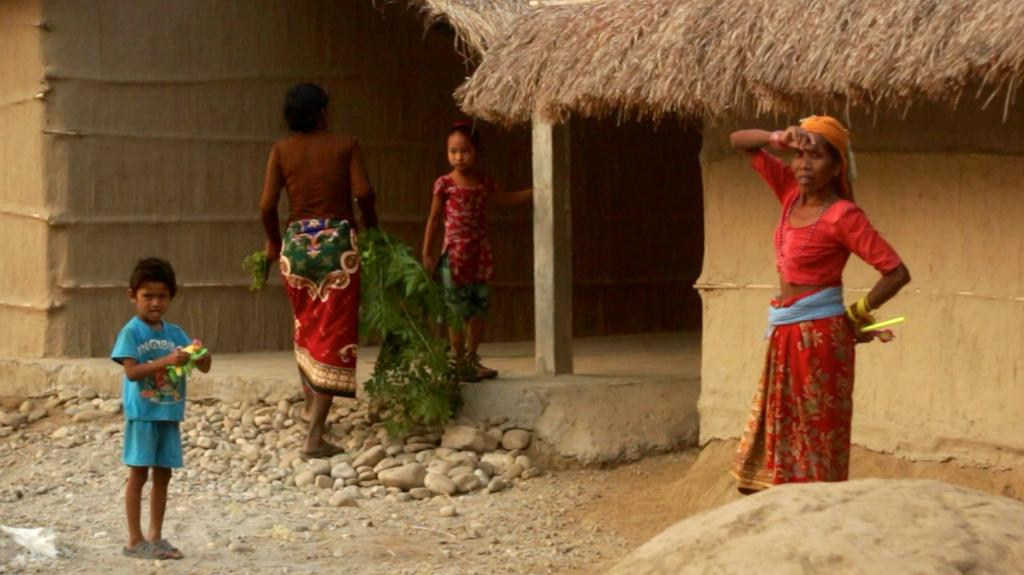What are the persons in the image doing? The persons in the image are standing on the ground. What is one of the persons holding in her hands? One of the persons is holding a bunch of leaves in her hands. What can be seen in the background of the image? In the background of the image, there are people, walls, stones, and sand. What type of ornament is hanging from the son's stem in the image? There is no son or stem present in the image, and therefore no such ornament can be observed. 